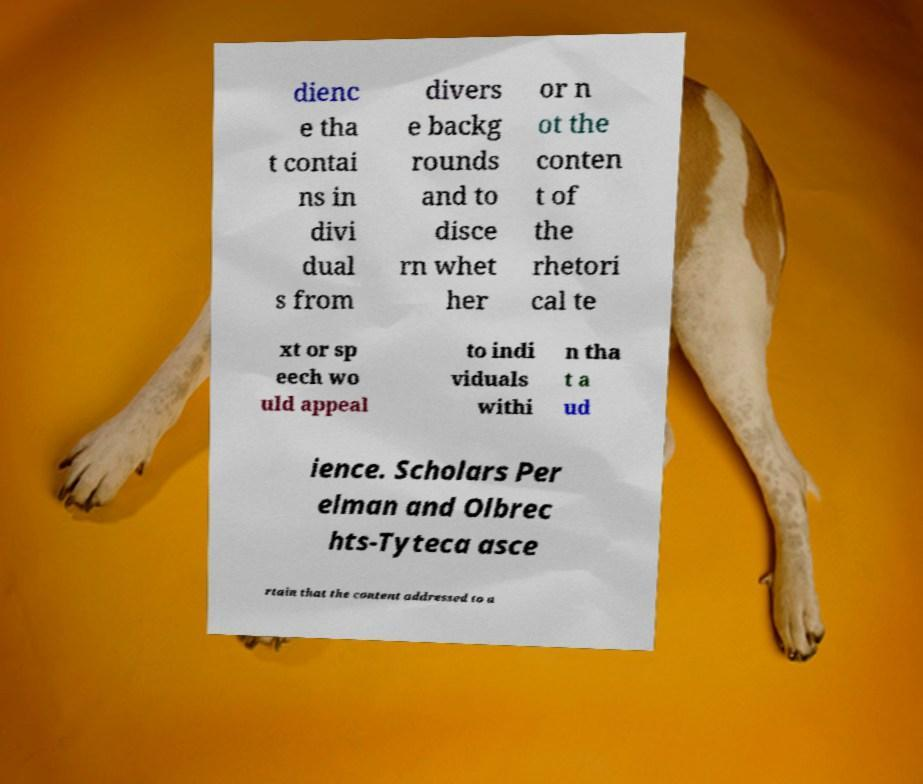What messages or text are displayed in this image? I need them in a readable, typed format. dienc e tha t contai ns in divi dual s from divers e backg rounds and to disce rn whet her or n ot the conten t of the rhetori cal te xt or sp eech wo uld appeal to indi viduals withi n tha t a ud ience. Scholars Per elman and Olbrec hts-Tyteca asce rtain that the content addressed to a 